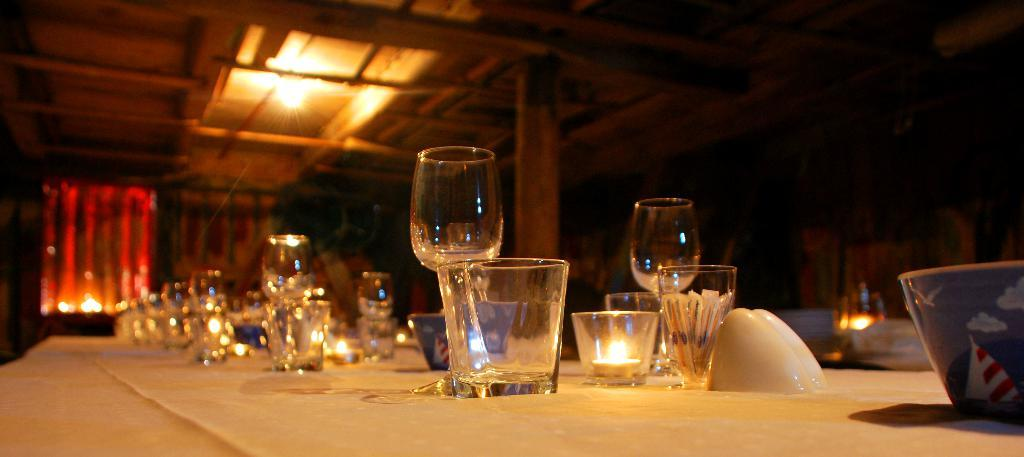What type of glasses are on the dining table in the image? There are wine glasses on the dining table in the image. What might be the purpose of these glasses on the table? The wine glasses might be used for serving or consuming wine during a meal. What type of holiday is being celebrated in the image? There is no indication of a holiday being celebrated in the image, as it only features wine glasses on a dining table. 